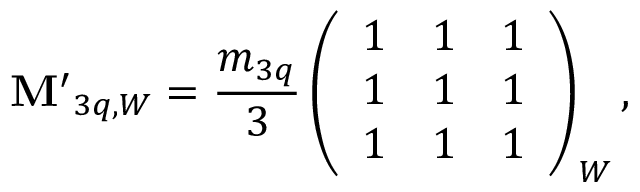Convert formula to latex. <formula><loc_0><loc_0><loc_500><loc_500>{ M ^ { \prime } } _ { 3 q , W } = { \frac { m _ { 3 q } } { 3 } } \left ( \begin{array} { l l l } { 1 } & { 1 } & { 1 } \\ { 1 } & { 1 } & { 1 } \\ { 1 } & { 1 } & { 1 } \end{array} \right ) _ { W } ,</formula> 